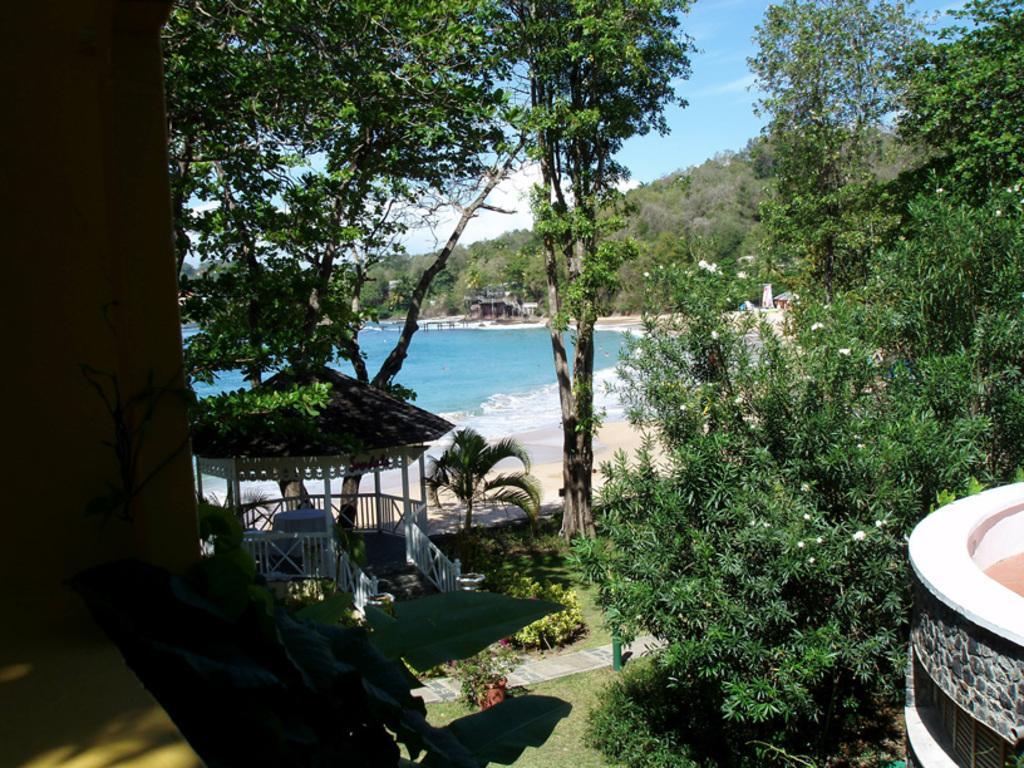In one or two sentences, can you explain what this image depicts? In the image on the right side there is a wall. And there is a hut with roof, poles and railings. And also there are many trees. Behind them there is water and also there is a sea shore. And there is a hill with trees. At the top of the image, behind the trees there is sky. 